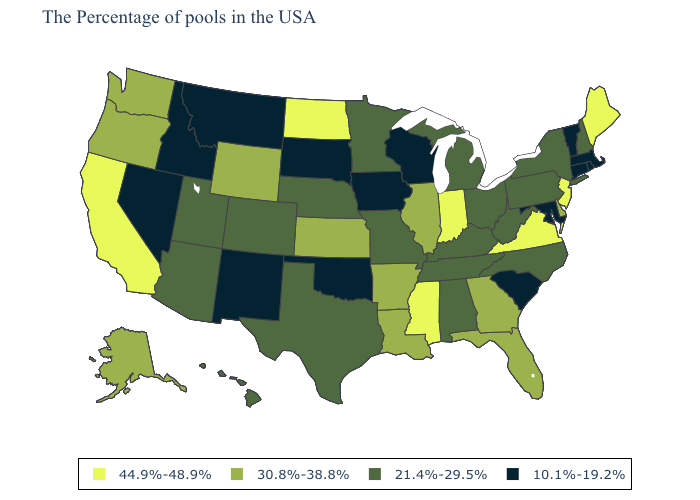Name the states that have a value in the range 30.8%-38.8%?
Quick response, please. Delaware, Florida, Georgia, Illinois, Louisiana, Arkansas, Kansas, Wyoming, Washington, Oregon, Alaska. Does the map have missing data?
Quick response, please. No. Name the states that have a value in the range 10.1%-19.2%?
Concise answer only. Massachusetts, Rhode Island, Vermont, Connecticut, Maryland, South Carolina, Wisconsin, Iowa, Oklahoma, South Dakota, New Mexico, Montana, Idaho, Nevada. Name the states that have a value in the range 44.9%-48.9%?
Write a very short answer. Maine, New Jersey, Virginia, Indiana, Mississippi, North Dakota, California. What is the lowest value in states that border North Carolina?
Short answer required. 10.1%-19.2%. What is the value of Oklahoma?
Concise answer only. 10.1%-19.2%. Does Indiana have the highest value in the MidWest?
Quick response, please. Yes. What is the value of Kentucky?
Concise answer only. 21.4%-29.5%. What is the highest value in the USA?
Answer briefly. 44.9%-48.9%. What is the highest value in the USA?
Concise answer only. 44.9%-48.9%. Name the states that have a value in the range 44.9%-48.9%?
Short answer required. Maine, New Jersey, Virginia, Indiana, Mississippi, North Dakota, California. What is the lowest value in the USA?
Concise answer only. 10.1%-19.2%. What is the value of Illinois?
Give a very brief answer. 30.8%-38.8%. Name the states that have a value in the range 21.4%-29.5%?
Write a very short answer. New Hampshire, New York, Pennsylvania, North Carolina, West Virginia, Ohio, Michigan, Kentucky, Alabama, Tennessee, Missouri, Minnesota, Nebraska, Texas, Colorado, Utah, Arizona, Hawaii. Does the first symbol in the legend represent the smallest category?
Give a very brief answer. No. 